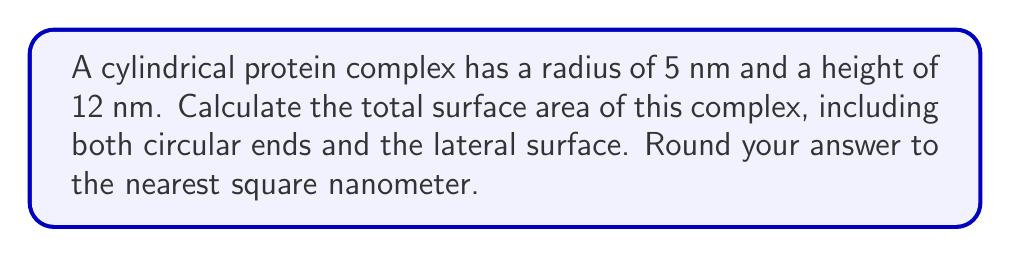Solve this math problem. To compute the surface area of a cylindrical protein complex, we need to consider three components:
1. The area of the top circular face
2. The area of the bottom circular face
3. The area of the lateral surface (curved side)

Let's calculate each component:

1. Area of one circular face:
   $$A_{circle} = \pi r^2 = \pi (5 \text{ nm})^2 = 25\pi \text{ nm}^2$$

2. Area of both circular faces:
   $$A_{circles} = 2 \times 25\pi \text{ nm}^2 = 50\pi \text{ nm}^2$$

3. Area of the lateral surface:
   The lateral surface can be "unrolled" into a rectangle with width equal to the circumference of the circle and height equal to the height of the cylinder.
   $$A_{lateral} = 2\pi r h = 2\pi (5 \text{ nm})(12 \text{ nm}) = 120\pi \text{ nm}^2$$

4. Total surface area:
   $$A_{total} = A_{circles} + A_{lateral} = 50\pi \text{ nm}^2 + 120\pi \text{ nm}^2 = 170\pi \text{ nm}^2$$

5. Calculate the numerical value:
   $$A_{total} = 170\pi \approx 533.8 \text{ nm}^2$$

6. Rounding to the nearest square nanometer:
   $$A_{total} \approx 534 \text{ nm}^2$$
Answer: 534 nm² 